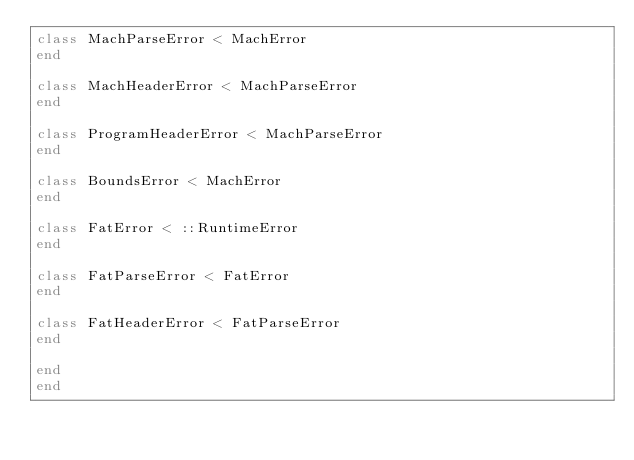Convert code to text. <code><loc_0><loc_0><loc_500><loc_500><_Ruby_>class MachParseError < MachError
end

class MachHeaderError < MachParseError
end

class ProgramHeaderError < MachParseError
end

class BoundsError < MachError
end

class FatError < ::RuntimeError
end

class FatParseError < FatError
end

class FatHeaderError < FatParseError
end

end
end
</code> 